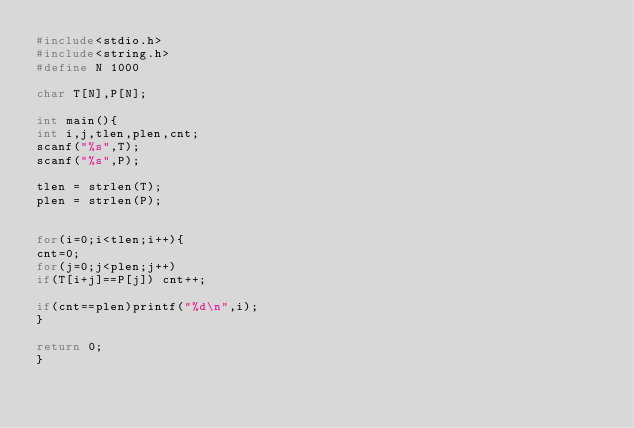<code> <loc_0><loc_0><loc_500><loc_500><_C_>#include<stdio.h>
#include<string.h>
#define N 1000

char T[N],P[N];

int main(){
int i,j,tlen,plen,cnt;
scanf("%s",T);
scanf("%s",P);

tlen = strlen(T);
plen = strlen(P);


for(i=0;i<tlen;i++){
cnt=0;
for(j=0;j<plen;j++)
if(T[i+j]==P[j]) cnt++;

if(cnt==plen)printf("%d\n",i);
}

return 0;
}</code> 